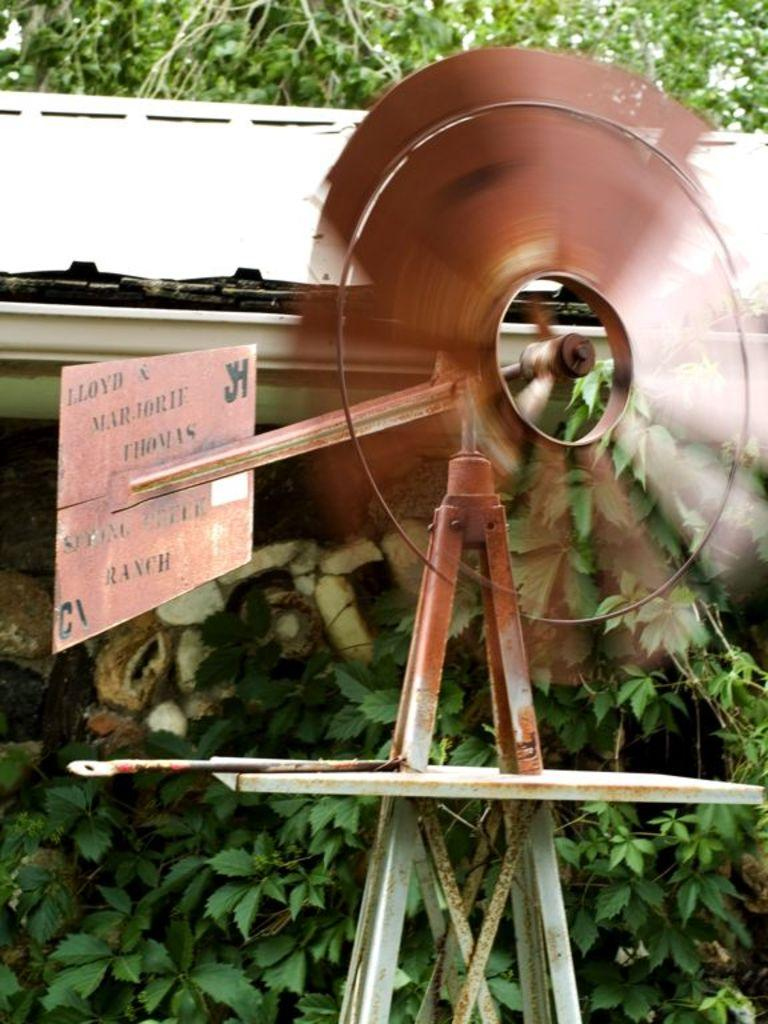What is the main structure in the image? There is a windmill in the image. What other objects can be seen in the image? There is a board and a rod visible in the image. What can be seen in the background of the image? Plants and a white color object are visible in the background of the image. How many trains can be seen passing by the windmill in the image? There are no trains visible in the image; it only features a windmill, a board, and a rod. What type of flower is growing near the windmill in the image? There are no flowers present in the image; only plants and a white color object can be seen in the background. 